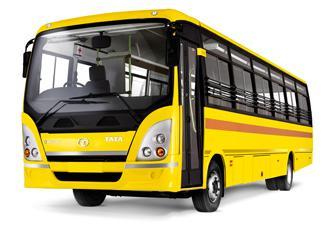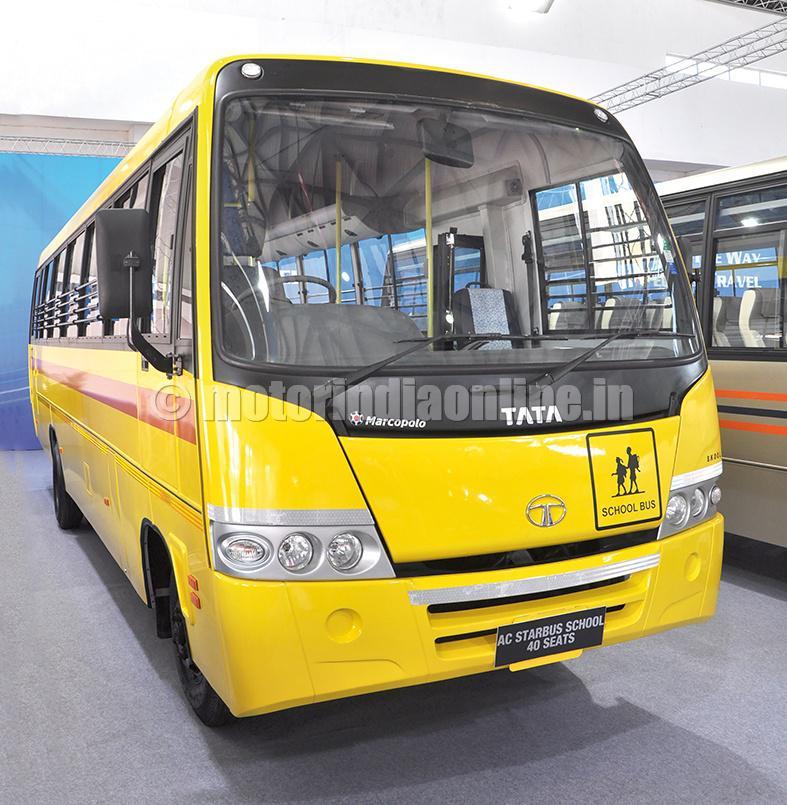The first image is the image on the left, the second image is the image on the right. Given the left and right images, does the statement "Both yellow buses are facing the same direction." hold true? Answer yes or no. No. The first image is the image on the left, the second image is the image on the right. Considering the images on both sides, is "The vehicles are facing in the same direction." valid? Answer yes or no. No. 